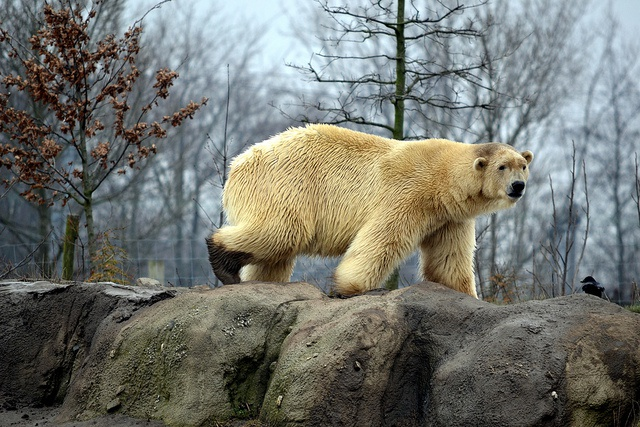Describe the objects in this image and their specific colors. I can see a bear in darkgray, tan, khaki, and olive tones in this image. 